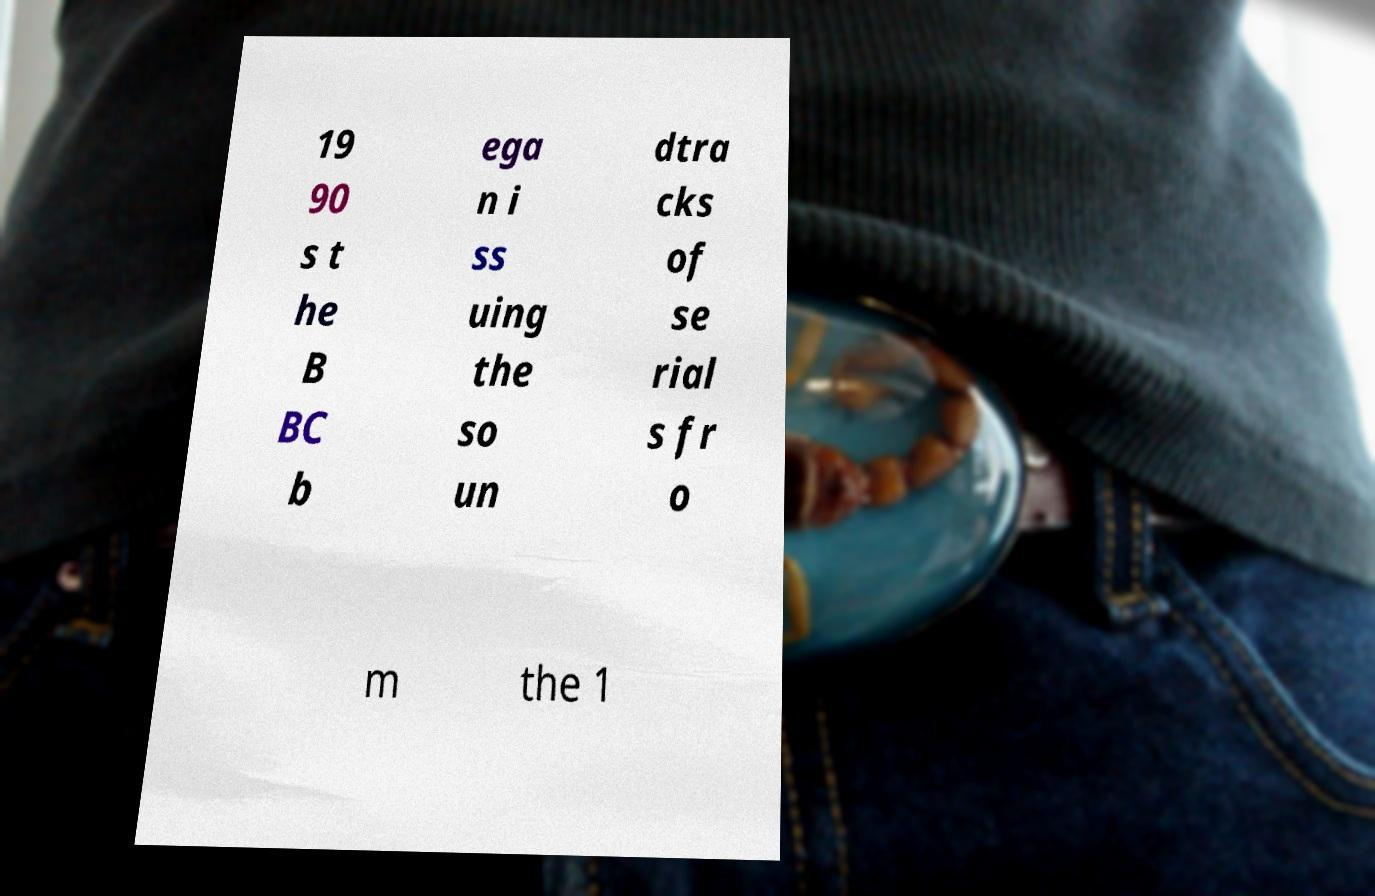There's text embedded in this image that I need extracted. Can you transcribe it verbatim? 19 90 s t he B BC b ega n i ss uing the so un dtra cks of se rial s fr o m the 1 